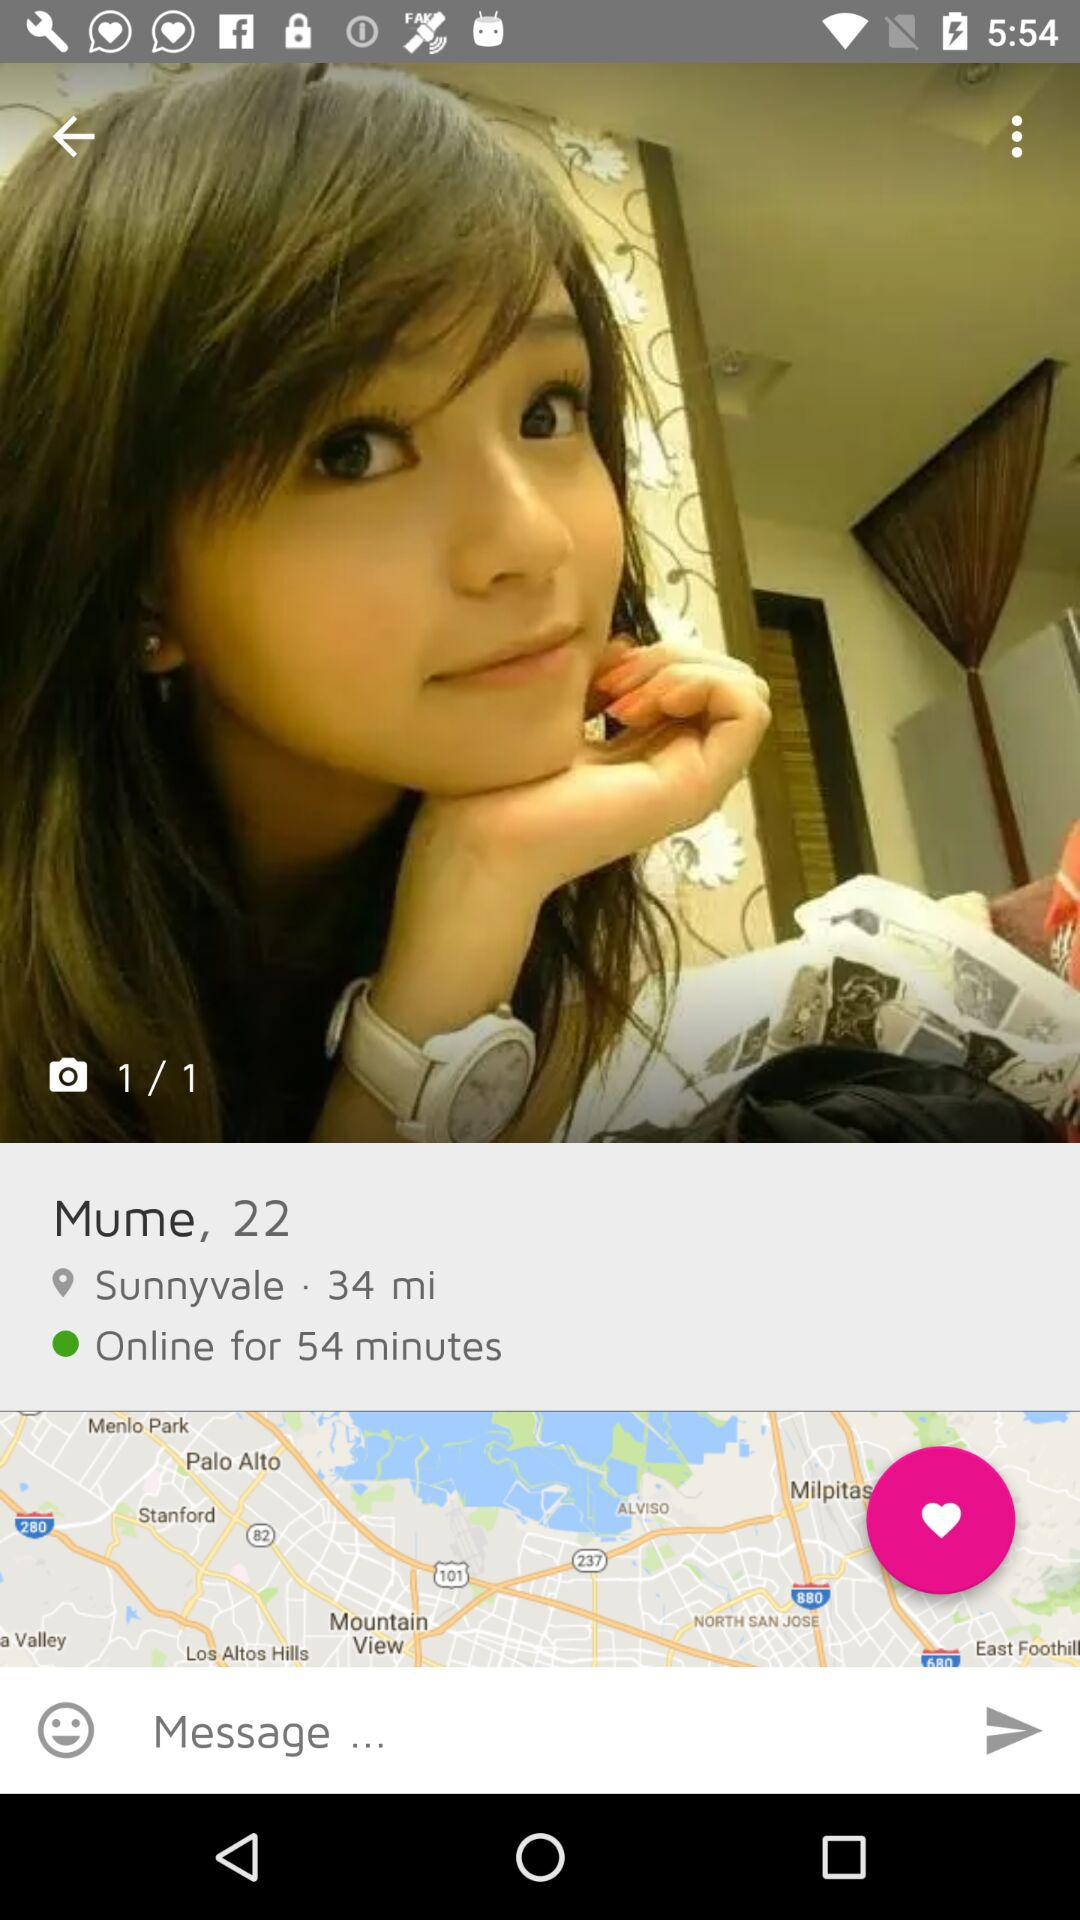For how long has the user been online? The user has been online for 54 minutes. 